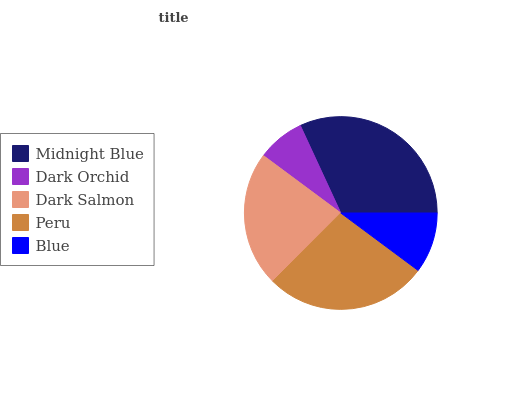Is Dark Orchid the minimum?
Answer yes or no. Yes. Is Midnight Blue the maximum?
Answer yes or no. Yes. Is Dark Salmon the minimum?
Answer yes or no. No. Is Dark Salmon the maximum?
Answer yes or no. No. Is Dark Salmon greater than Dark Orchid?
Answer yes or no. Yes. Is Dark Orchid less than Dark Salmon?
Answer yes or no. Yes. Is Dark Orchid greater than Dark Salmon?
Answer yes or no. No. Is Dark Salmon less than Dark Orchid?
Answer yes or no. No. Is Dark Salmon the high median?
Answer yes or no. Yes. Is Dark Salmon the low median?
Answer yes or no. Yes. Is Midnight Blue the high median?
Answer yes or no. No. Is Midnight Blue the low median?
Answer yes or no. No. 